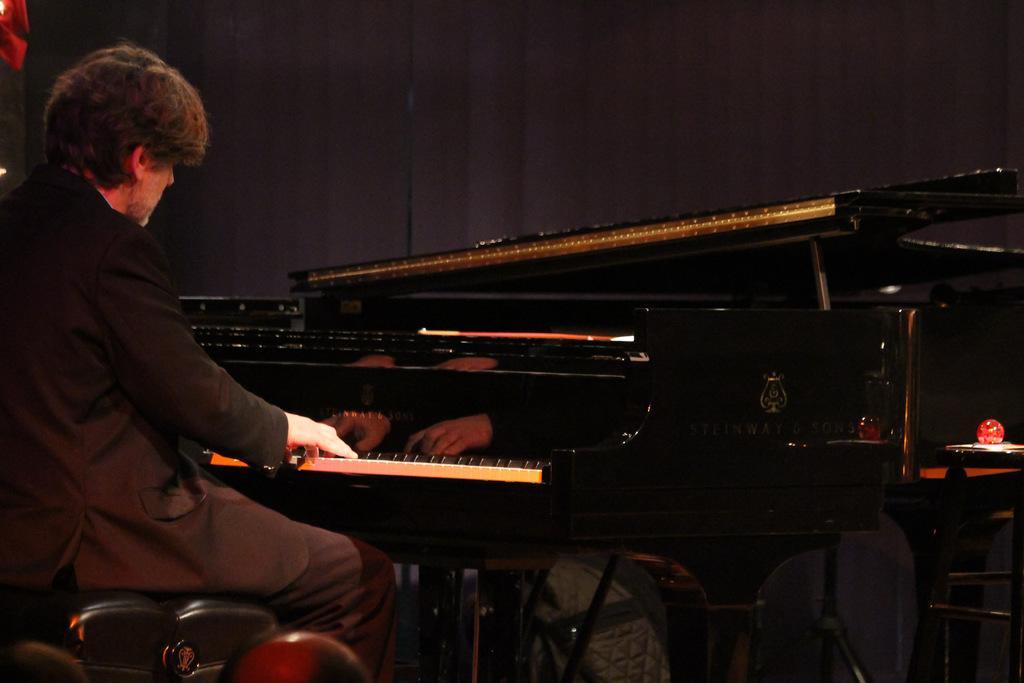How would you summarize this image in a sentence or two? In this image I can see a man is sitting in front of a piano. 